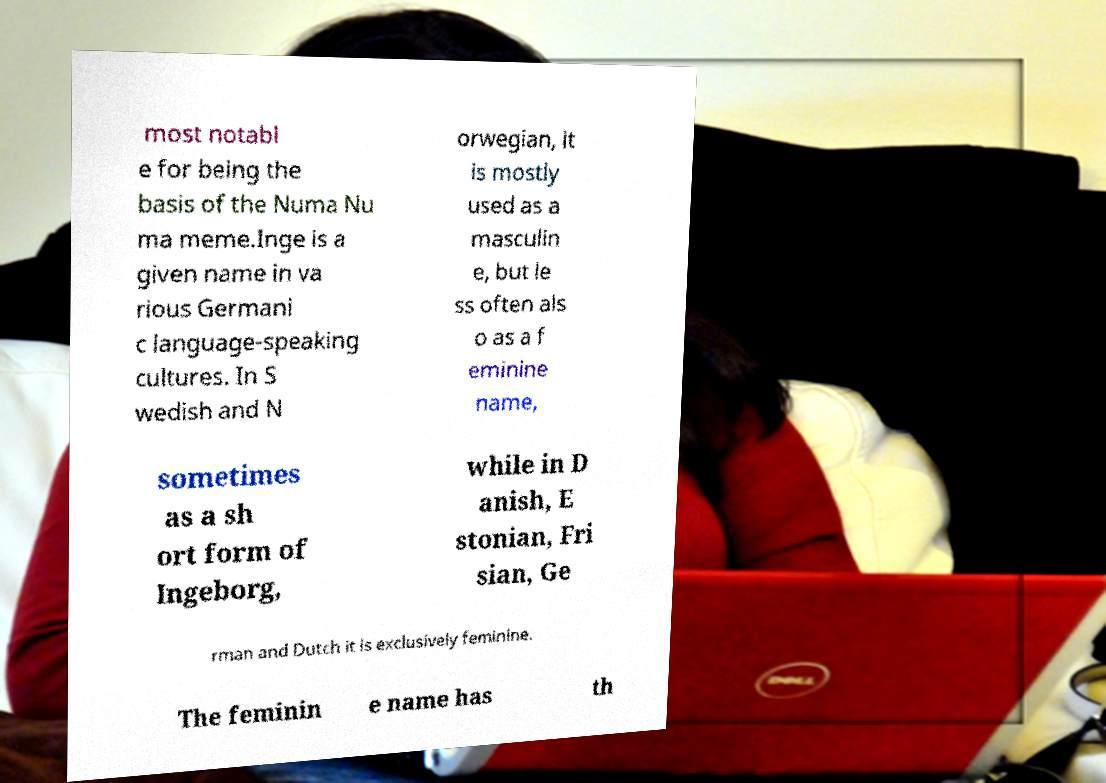Can you read and provide the text displayed in the image?This photo seems to have some interesting text. Can you extract and type it out for me? most notabl e for being the basis of the Numa Nu ma meme.Inge is a given name in va rious Germani c language-speaking cultures. In S wedish and N orwegian, it is mostly used as a masculin e, but le ss often als o as a f eminine name, sometimes as a sh ort form of Ingeborg, while in D anish, E stonian, Fri sian, Ge rman and Dutch it is exclusively feminine. The feminin e name has th 